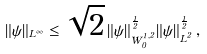<formula> <loc_0><loc_0><loc_500><loc_500>\| \psi \| _ { L ^ { \infty } } \leq \sqrt { 2 } \, \| \psi \| _ { W ^ { 1 , 2 } _ { 0 } } ^ { \frac { 1 } { 2 } } \| \psi \| _ { L ^ { 2 } } ^ { \frac { 1 } { 2 } } \, ,</formula> 